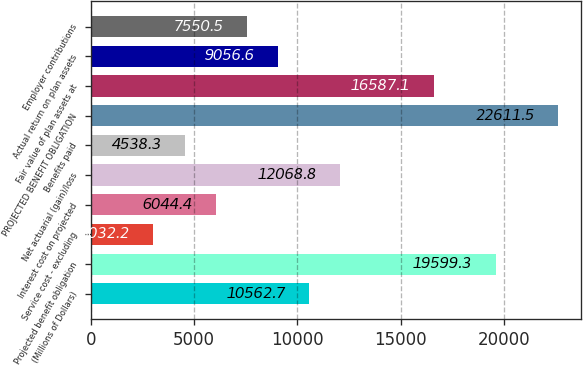Convert chart to OTSL. <chart><loc_0><loc_0><loc_500><loc_500><bar_chart><fcel>(Millions of Dollars)<fcel>Projected benefit obligation<fcel>Service cost - excluding<fcel>Interest cost on projected<fcel>Net actuarial (gain)/loss<fcel>Benefits paid<fcel>PROJECTED BENEFIT OBLIGATION<fcel>Fair value of plan assets at<fcel>Actual return on plan assets<fcel>Employer contributions<nl><fcel>10562.7<fcel>19599.3<fcel>3032.2<fcel>6044.4<fcel>12068.8<fcel>4538.3<fcel>22611.5<fcel>16587.1<fcel>9056.6<fcel>7550.5<nl></chart> 